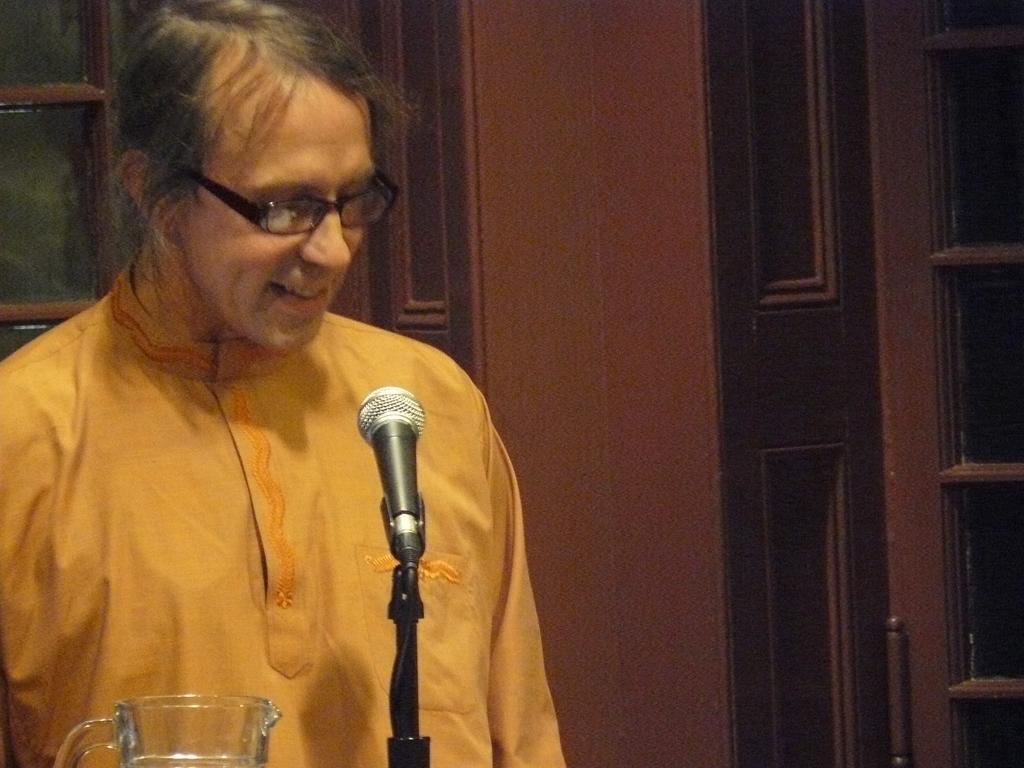How would you summarize this image in a sentence or two? In this image there is a person standing, in front of the person there is a mic and a jar. In the background there is a window and a door. 